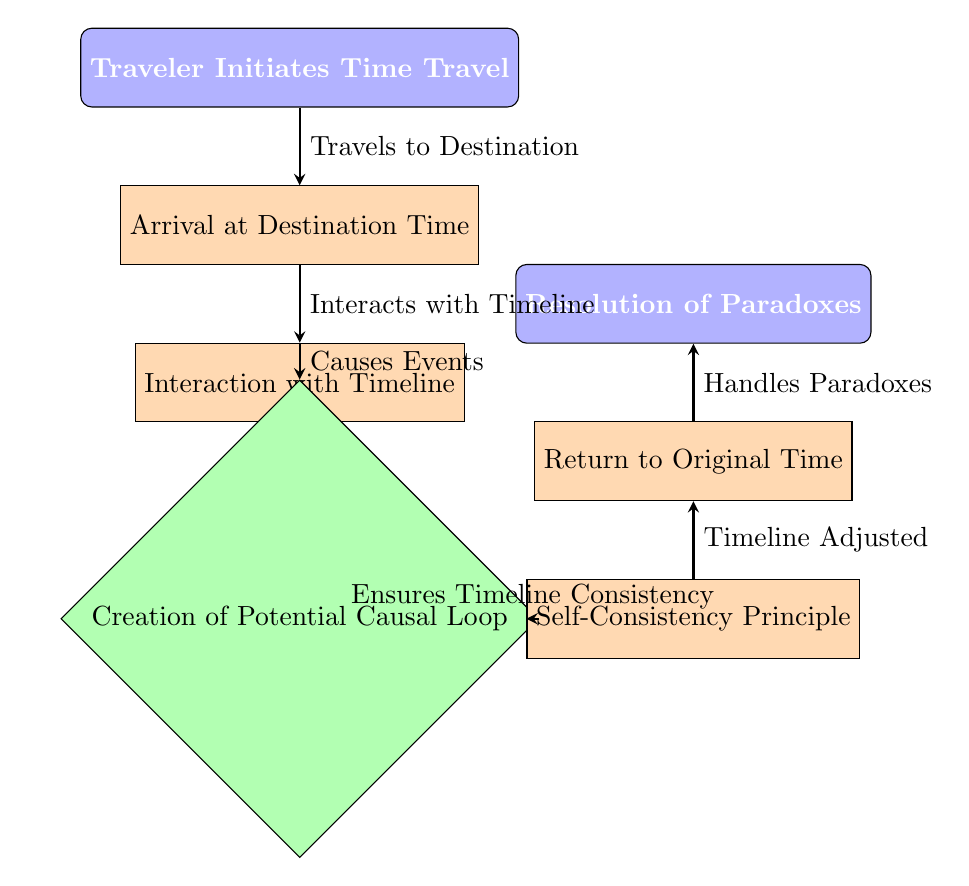What is the first node in the diagram? The first node in the diagram is "Traveler Initiates Time Travel," as indicated at the top of the flow chart.
Answer: Traveler Initiates Time Travel How many edges are present in the diagram? By counting the arrows connecting the nodes, there are six edges present in the diagram.
Answer: 6 What does the traveler do after arriving at the destination? Following the arrival at the destination time, the traveler interacts with the timeline, as indicated by the connecting arrow.
Answer: Interaction with Timeline What principle ensures that no contradictions arise in the timeline? The principle ensuring no contradictions in the timeline is the "Self-Consistency Principle," which is specified in one of the nodes.
Answer: Self-Consistency Principle What happens if a causal loop is created? If a causal loop is created, it leads to the "Self-Consistency Principle," which ensures timeline consistency, as shown in the flow between these nodes.
Answer: Ensures Timeline Consistency After the traveler returns to the original time, what process follows? After returning to the original time, the next step is the "Resolution of Paradoxes," which addresses any paradoxes encountered during the journey.
Answer: Resolution of Paradoxes What action connects the "Interaction with Timeline" and "Creation of Potential Causal Loop" nodes? The action connecting these two nodes is "Causes Events," indicating the effect that interactions can have on the timeline.
Answer: Causes Events What is the relationship between "Return to Original Time" and "Resolution of Paradoxes"? The relationship is that the return to the original time leads directly to the resolution of paradoxes, as shown by the connecting arrow in the diagram.
Answer: Handles Paradoxes What does the "Traveler Initiates Time Travel" node represent? The "Traveler Initiates Time Travel" node represents the starting action of the time travel process, marking the beginning of the flowchart.
Answer: Traveler Initiates Time Travel 